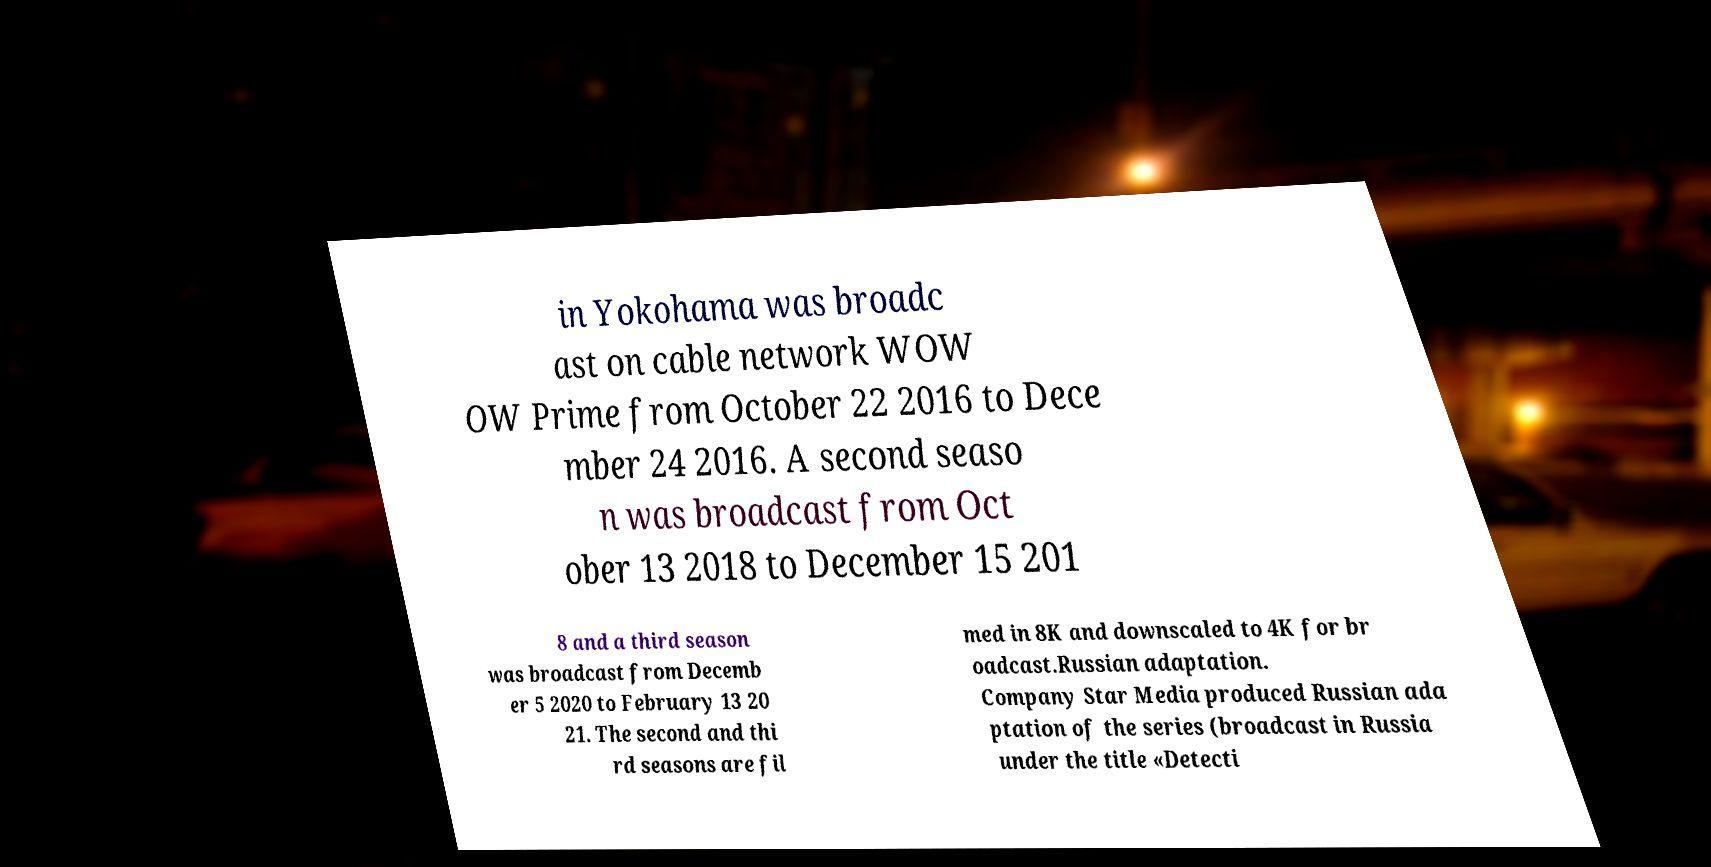For documentation purposes, I need the text within this image transcribed. Could you provide that? in Yokohama was broadc ast on cable network WOW OW Prime from October 22 2016 to Dece mber 24 2016. A second seaso n was broadcast from Oct ober 13 2018 to December 15 201 8 and a third season was broadcast from Decemb er 5 2020 to February 13 20 21. The second and thi rd seasons are fil med in 8K and downscaled to 4K for br oadcast.Russian adaptation. Company Star Media produced Russian ada ptation of the series (broadcast in Russia under the title «Detecti 